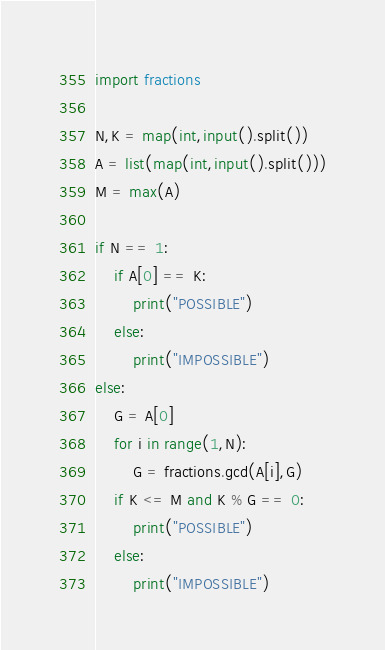Convert code to text. <code><loc_0><loc_0><loc_500><loc_500><_Python_>import fractions

N,K = map(int,input().split())
A = list(map(int,input().split()))
M = max(A)

if N == 1:
    if A[0] == K:
        print("POSSIBLE")
    else:
        print("IMPOSSIBLE")
else:
    G = A[0]
    for i in range(1,N):
        G = fractions.gcd(A[i],G)
    if K <= M and K % G == 0:
        print("POSSIBLE")
    else:
        print("IMPOSSIBLE")</code> 